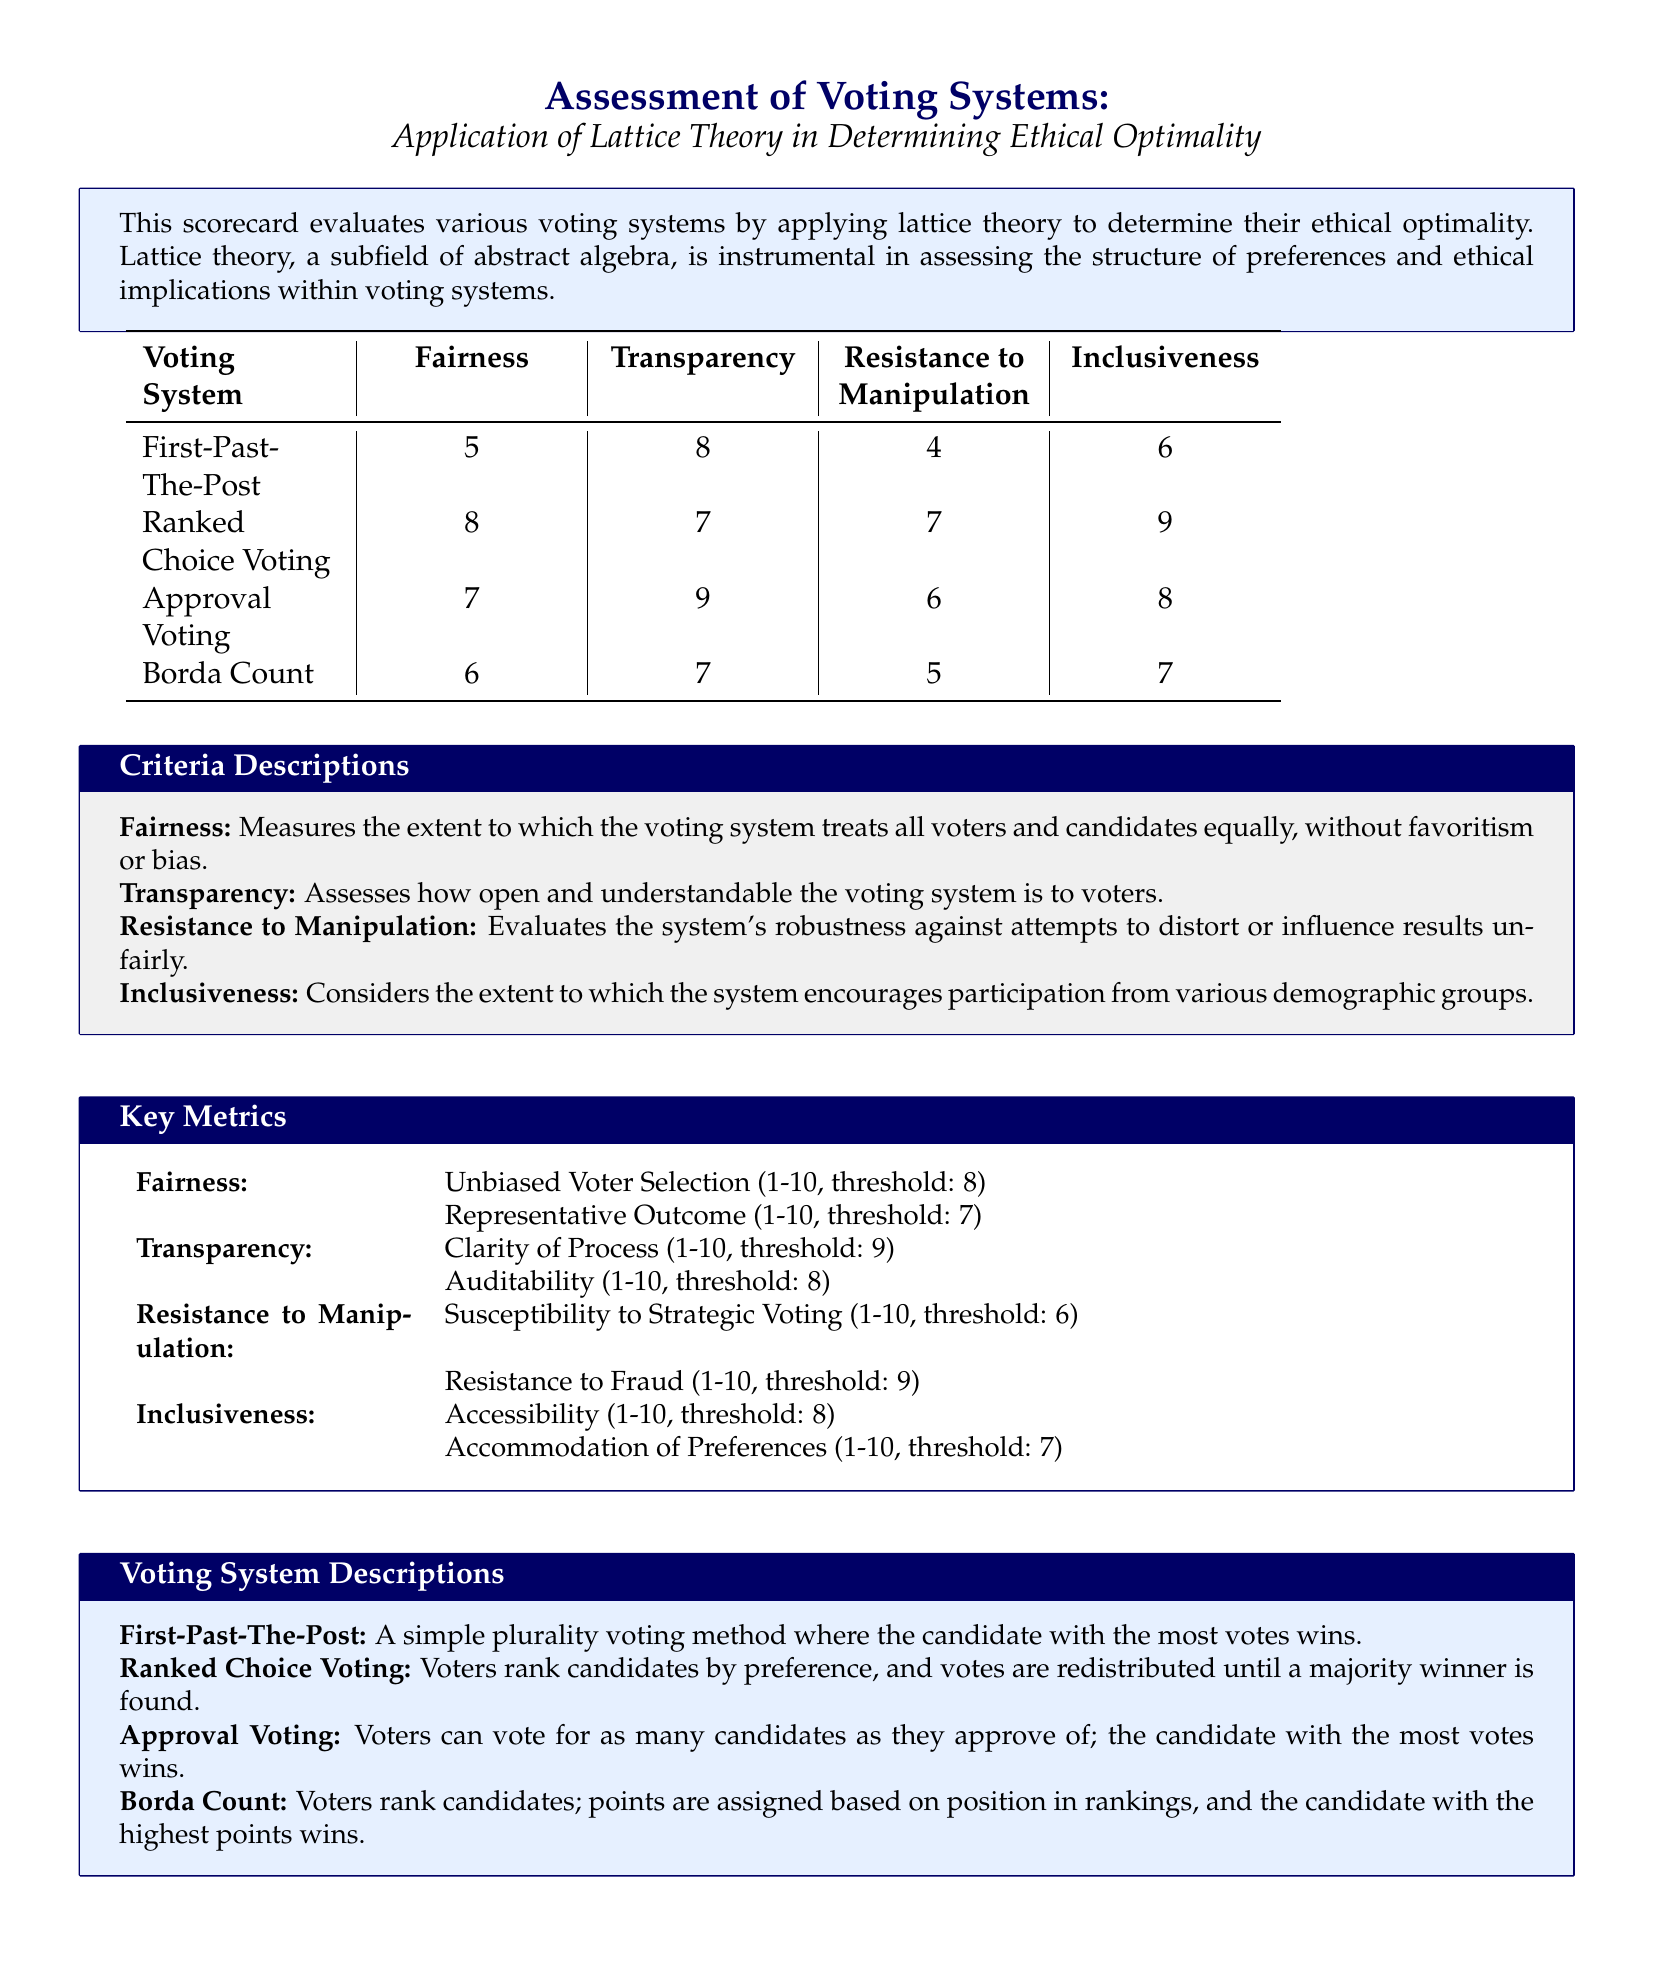What is the highest score for Fairness? The highest score for Fairness is taken from the voting systems listed, where Ranked Choice Voting has a score of 8.
Answer: 8 Which voting system has the lowest score for Resistance to Manipulation? The lowest score for Resistance to Manipulation is found in the First-Past-The-Post system with a score of 4.
Answer: 4 What criteria is used to assess Transparency? Transparency is assessed by two key metrics: Clarity of Process and Auditability, from which the highest score across voting systems is evaluated.
Answer: Clarity of Process Which voting system has the highest score for Inclusiveness? The highest score for Inclusiveness is attributed to Ranked Choice Voting with a score of 9.
Answer: 9 How many metrics are used to evaluate Fairness? Fairness is measured using two specific metrics mentioned in the document, which include Unbiased Voter Selection and Representative Outcome.
Answer: 2 What is the threshold score for Auditability? The document specifies a threshold score of 8 for Auditability, meaning any score below this indicates a lack of transparency.
Answer: 8 What is the voting method that allocates points based on rankings? The voting method described in the document that assigns points based on voter rankings is the Borda Count.
Answer: Borda Count Which voting system offers the most resistance to manipulation? Among the voting systems evaluated, Ranked Choice Voting has the highest resistance to manipulation with a score of 7.
Answer: Ranked Choice Voting 